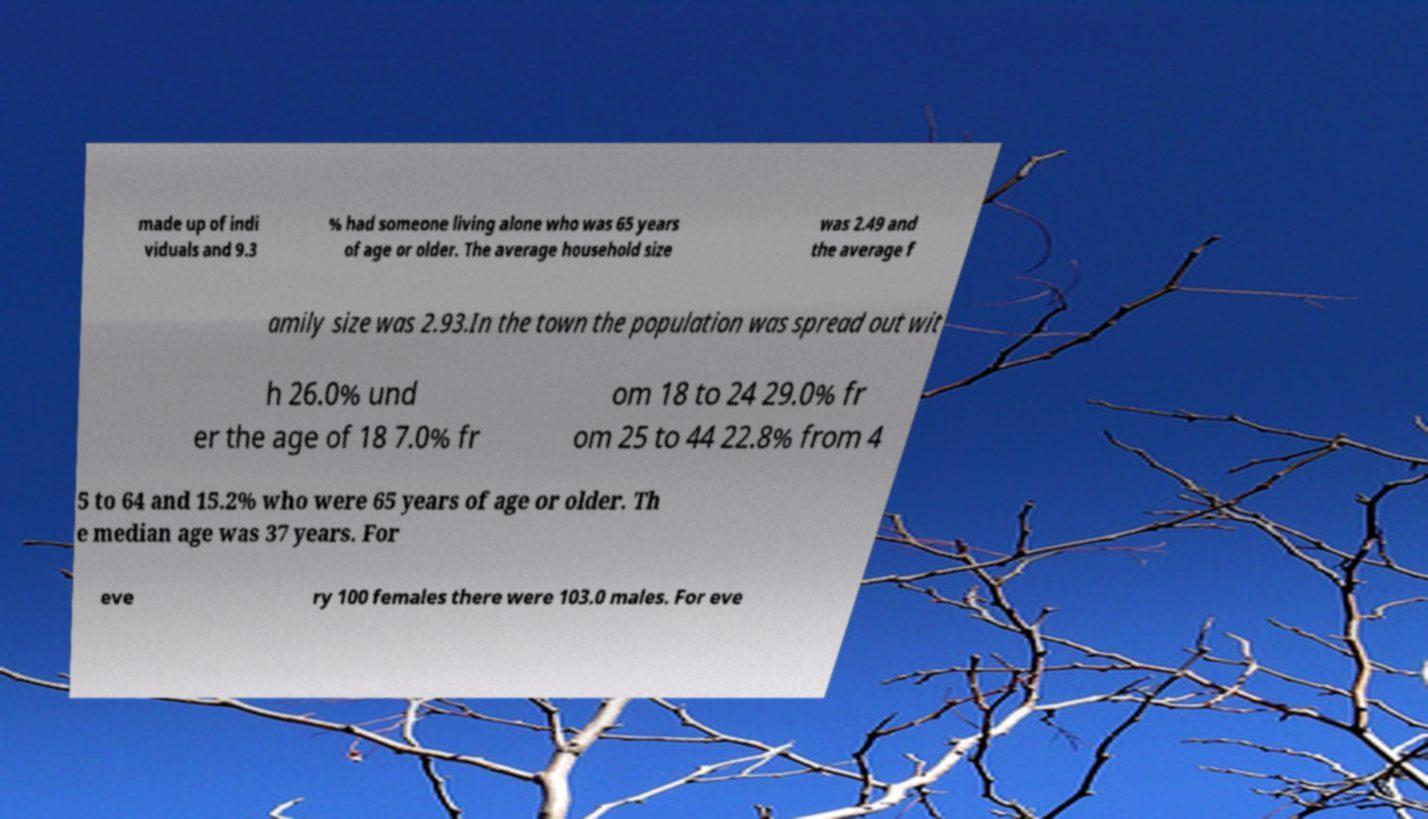What messages or text are displayed in this image? I need them in a readable, typed format. made up of indi viduals and 9.3 % had someone living alone who was 65 years of age or older. The average household size was 2.49 and the average f amily size was 2.93.In the town the population was spread out wit h 26.0% und er the age of 18 7.0% fr om 18 to 24 29.0% fr om 25 to 44 22.8% from 4 5 to 64 and 15.2% who were 65 years of age or older. Th e median age was 37 years. For eve ry 100 females there were 103.0 males. For eve 